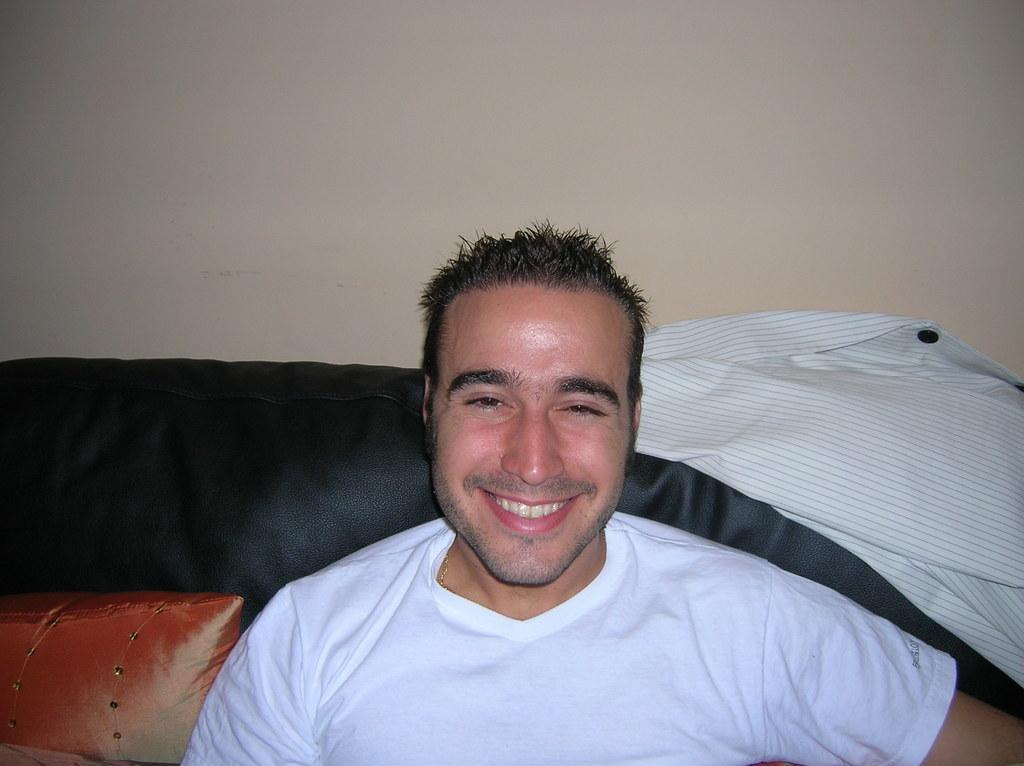Describe this image in one or two sentences. In this image there is a man wearing white t-shirt is sitting on a sofa with a smiling face. In the right there is a shirt. In the background there is wall. 